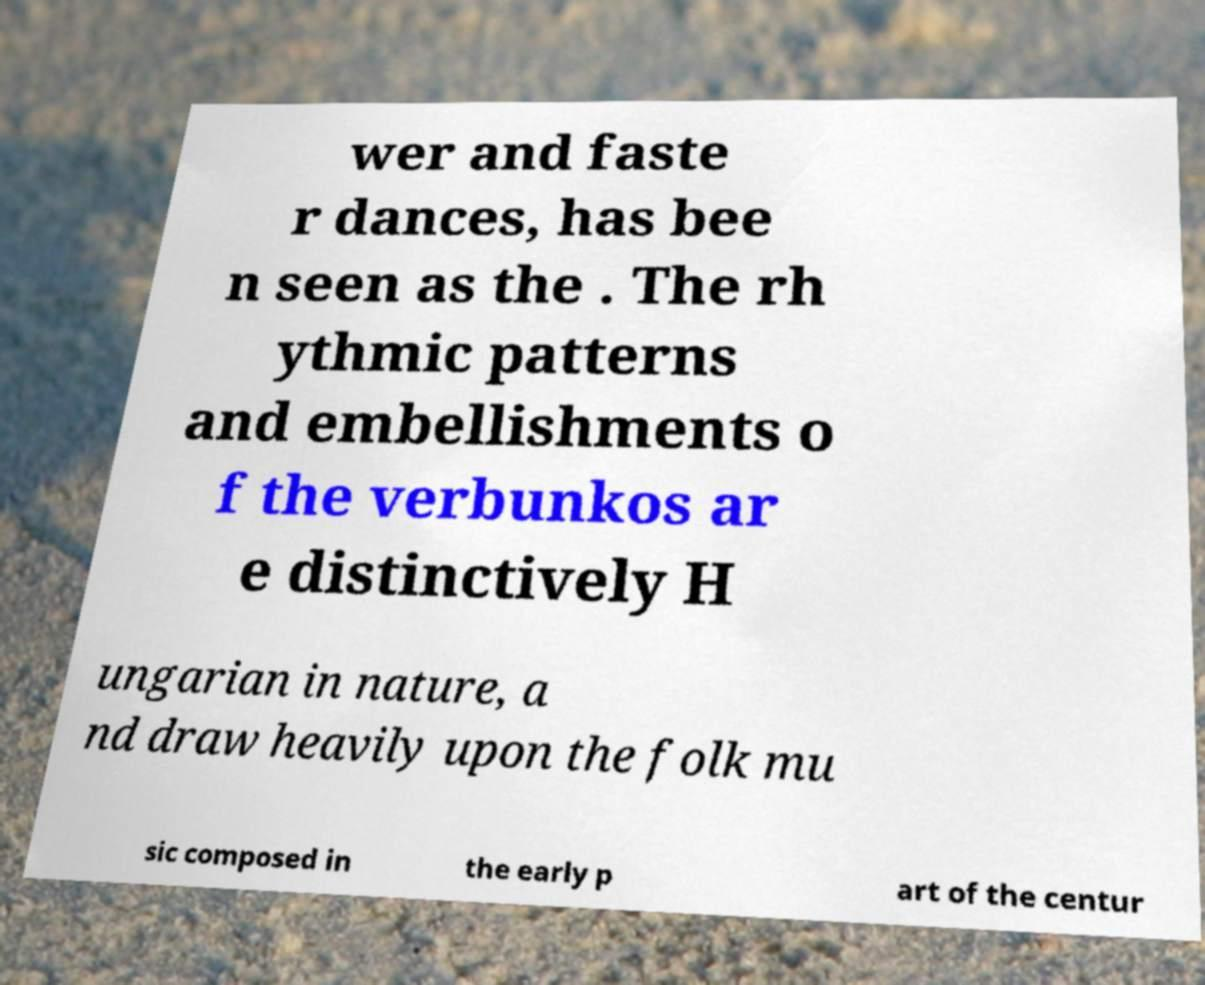Please read and relay the text visible in this image. What does it say? wer and faste r dances, has bee n seen as the . The rh ythmic patterns and embellishments o f the verbunkos ar e distinctively H ungarian in nature, a nd draw heavily upon the folk mu sic composed in the early p art of the centur 